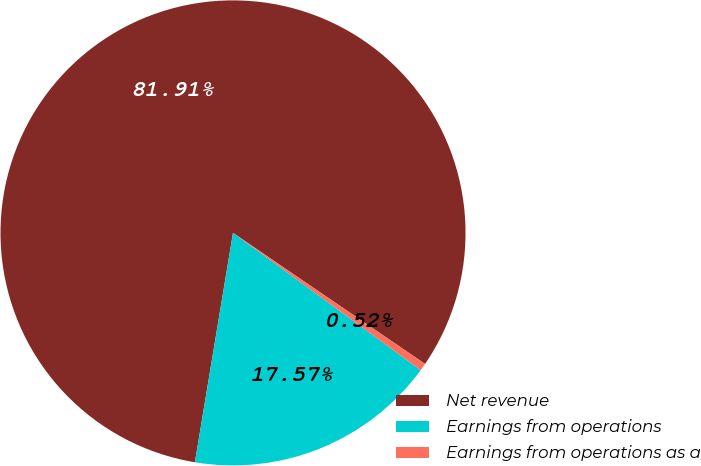Convert chart. <chart><loc_0><loc_0><loc_500><loc_500><pie_chart><fcel>Net revenue<fcel>Earnings from operations<fcel>Earnings from operations as a<nl><fcel>81.91%<fcel>17.57%<fcel>0.52%<nl></chart> 